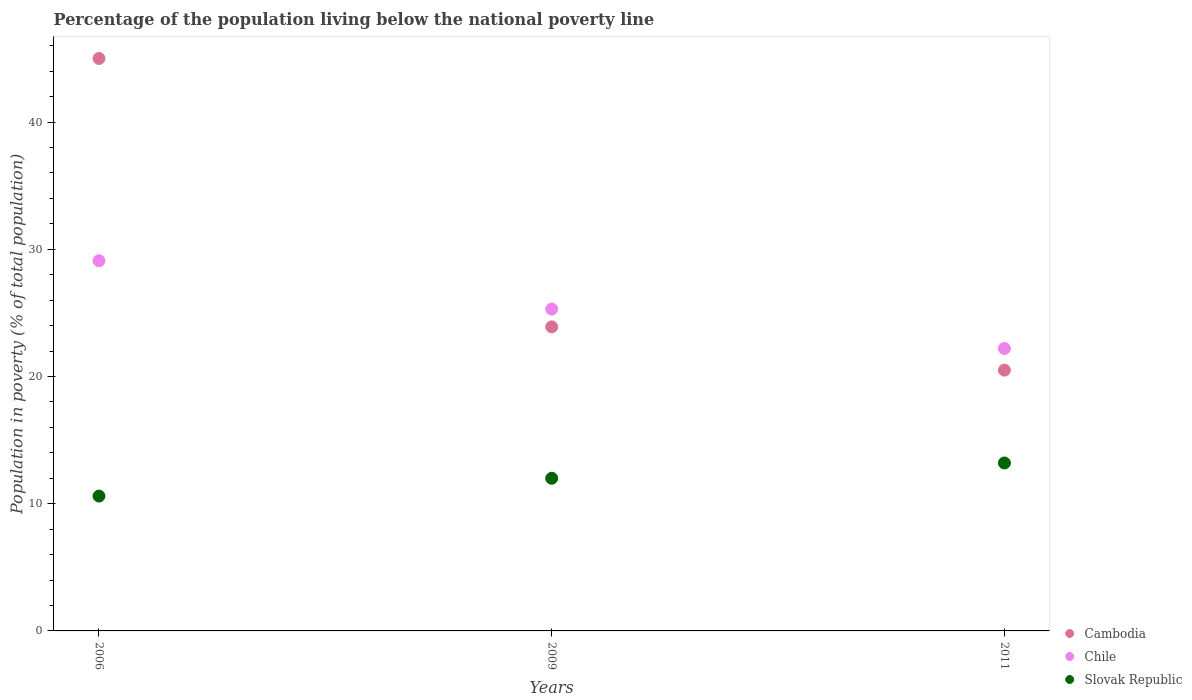How many different coloured dotlines are there?
Provide a succinct answer. 3. What is the percentage of the population living below the national poverty line in Cambodia in 2009?
Offer a very short reply. 23.9. Across all years, what is the minimum percentage of the population living below the national poverty line in Cambodia?
Your answer should be compact. 20.5. In which year was the percentage of the population living below the national poverty line in Chile maximum?
Keep it short and to the point. 2006. What is the total percentage of the population living below the national poverty line in Cambodia in the graph?
Your answer should be compact. 89.4. What is the difference between the percentage of the population living below the national poverty line in Cambodia in 2006 and that in 2009?
Keep it short and to the point. 21.1. What is the difference between the percentage of the population living below the national poverty line in Cambodia in 2006 and the percentage of the population living below the national poverty line in Slovak Republic in 2011?
Offer a very short reply. 31.8. What is the average percentage of the population living below the national poverty line in Chile per year?
Make the answer very short. 25.53. In the year 2006, what is the difference between the percentage of the population living below the national poverty line in Slovak Republic and percentage of the population living below the national poverty line in Chile?
Make the answer very short. -18.5. In how many years, is the percentage of the population living below the national poverty line in Cambodia greater than 10 %?
Keep it short and to the point. 3. What is the ratio of the percentage of the population living below the national poverty line in Cambodia in 2006 to that in 2011?
Provide a short and direct response. 2.2. Is the percentage of the population living below the national poverty line in Cambodia in 2009 less than that in 2011?
Make the answer very short. No. What is the difference between the highest and the second highest percentage of the population living below the national poverty line in Chile?
Give a very brief answer. 3.8. Is the percentage of the population living below the national poverty line in Chile strictly greater than the percentage of the population living below the national poverty line in Slovak Republic over the years?
Keep it short and to the point. Yes. How many years are there in the graph?
Make the answer very short. 3. Are the values on the major ticks of Y-axis written in scientific E-notation?
Offer a very short reply. No. Does the graph contain grids?
Offer a terse response. No. Where does the legend appear in the graph?
Provide a succinct answer. Bottom right. What is the title of the graph?
Your response must be concise. Percentage of the population living below the national poverty line. Does "Least developed countries" appear as one of the legend labels in the graph?
Keep it short and to the point. No. What is the label or title of the X-axis?
Ensure brevity in your answer.  Years. What is the label or title of the Y-axis?
Provide a short and direct response. Population in poverty (% of total population). What is the Population in poverty (% of total population) of Cambodia in 2006?
Ensure brevity in your answer.  45. What is the Population in poverty (% of total population) of Chile in 2006?
Provide a short and direct response. 29.1. What is the Population in poverty (% of total population) of Cambodia in 2009?
Offer a very short reply. 23.9. What is the Population in poverty (% of total population) of Chile in 2009?
Make the answer very short. 25.3. What is the Population in poverty (% of total population) of Slovak Republic in 2009?
Ensure brevity in your answer.  12. What is the Population in poverty (% of total population) of Cambodia in 2011?
Your answer should be very brief. 20.5. What is the Population in poverty (% of total population) of Chile in 2011?
Provide a short and direct response. 22.2. What is the Population in poverty (% of total population) of Slovak Republic in 2011?
Give a very brief answer. 13.2. Across all years, what is the maximum Population in poverty (% of total population) in Cambodia?
Your response must be concise. 45. Across all years, what is the maximum Population in poverty (% of total population) in Chile?
Provide a short and direct response. 29.1. Across all years, what is the minimum Population in poverty (% of total population) of Chile?
Offer a terse response. 22.2. Across all years, what is the minimum Population in poverty (% of total population) of Slovak Republic?
Offer a very short reply. 10.6. What is the total Population in poverty (% of total population) of Cambodia in the graph?
Keep it short and to the point. 89.4. What is the total Population in poverty (% of total population) of Chile in the graph?
Provide a short and direct response. 76.6. What is the total Population in poverty (% of total population) of Slovak Republic in the graph?
Offer a very short reply. 35.8. What is the difference between the Population in poverty (% of total population) of Cambodia in 2006 and that in 2009?
Ensure brevity in your answer.  21.1. What is the difference between the Population in poverty (% of total population) in Chile in 2006 and that in 2009?
Provide a succinct answer. 3.8. What is the difference between the Population in poverty (% of total population) of Cambodia in 2006 and that in 2011?
Ensure brevity in your answer.  24.5. What is the difference between the Population in poverty (% of total population) in Chile in 2006 and that in 2011?
Provide a succinct answer. 6.9. What is the difference between the Population in poverty (% of total population) of Slovak Republic in 2006 and that in 2011?
Your answer should be very brief. -2.6. What is the difference between the Population in poverty (% of total population) of Chile in 2009 and that in 2011?
Offer a very short reply. 3.1. What is the difference between the Population in poverty (% of total population) of Cambodia in 2006 and the Population in poverty (% of total population) of Chile in 2009?
Provide a succinct answer. 19.7. What is the difference between the Population in poverty (% of total population) of Cambodia in 2006 and the Population in poverty (% of total population) of Chile in 2011?
Ensure brevity in your answer.  22.8. What is the difference between the Population in poverty (% of total population) in Cambodia in 2006 and the Population in poverty (% of total population) in Slovak Republic in 2011?
Your answer should be very brief. 31.8. What is the difference between the Population in poverty (% of total population) of Chile in 2006 and the Population in poverty (% of total population) of Slovak Republic in 2011?
Provide a short and direct response. 15.9. What is the difference between the Population in poverty (% of total population) in Cambodia in 2009 and the Population in poverty (% of total population) in Chile in 2011?
Your answer should be compact. 1.7. What is the average Population in poverty (% of total population) of Cambodia per year?
Provide a short and direct response. 29.8. What is the average Population in poverty (% of total population) in Chile per year?
Ensure brevity in your answer.  25.53. What is the average Population in poverty (% of total population) in Slovak Republic per year?
Ensure brevity in your answer.  11.93. In the year 2006, what is the difference between the Population in poverty (% of total population) of Cambodia and Population in poverty (% of total population) of Slovak Republic?
Your answer should be compact. 34.4. In the year 2006, what is the difference between the Population in poverty (% of total population) in Chile and Population in poverty (% of total population) in Slovak Republic?
Provide a short and direct response. 18.5. In the year 2009, what is the difference between the Population in poverty (% of total population) in Cambodia and Population in poverty (% of total population) in Slovak Republic?
Offer a terse response. 11.9. In the year 2011, what is the difference between the Population in poverty (% of total population) of Chile and Population in poverty (% of total population) of Slovak Republic?
Make the answer very short. 9. What is the ratio of the Population in poverty (% of total population) of Cambodia in 2006 to that in 2009?
Your answer should be very brief. 1.88. What is the ratio of the Population in poverty (% of total population) in Chile in 2006 to that in 2009?
Provide a short and direct response. 1.15. What is the ratio of the Population in poverty (% of total population) of Slovak Republic in 2006 to that in 2009?
Ensure brevity in your answer.  0.88. What is the ratio of the Population in poverty (% of total population) of Cambodia in 2006 to that in 2011?
Your answer should be compact. 2.2. What is the ratio of the Population in poverty (% of total population) of Chile in 2006 to that in 2011?
Provide a succinct answer. 1.31. What is the ratio of the Population in poverty (% of total population) of Slovak Republic in 2006 to that in 2011?
Offer a very short reply. 0.8. What is the ratio of the Population in poverty (% of total population) in Cambodia in 2009 to that in 2011?
Ensure brevity in your answer.  1.17. What is the ratio of the Population in poverty (% of total population) in Chile in 2009 to that in 2011?
Your answer should be compact. 1.14. What is the difference between the highest and the second highest Population in poverty (% of total population) in Cambodia?
Your response must be concise. 21.1. What is the difference between the highest and the second highest Population in poverty (% of total population) in Slovak Republic?
Your answer should be compact. 1.2. What is the difference between the highest and the lowest Population in poverty (% of total population) in Cambodia?
Offer a very short reply. 24.5. 